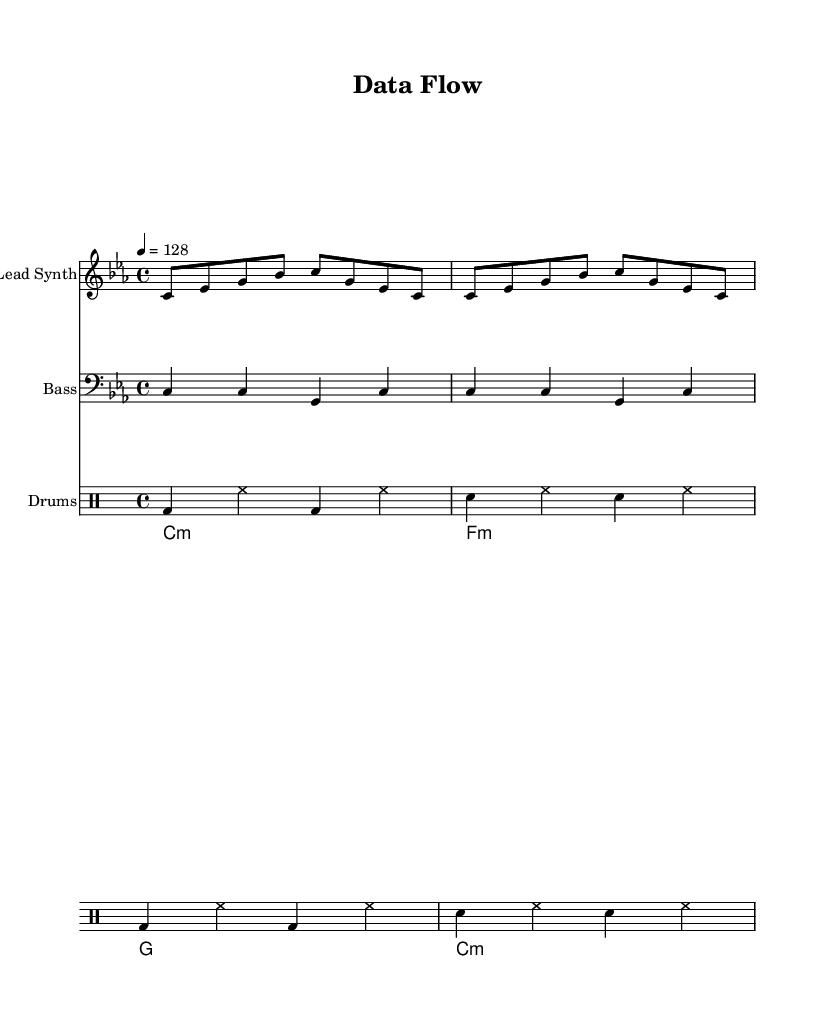What is the key signature of this music? The key signature is C minor, which consists of three flats (B♭, E♭, and A♭). This information can be found at the beginning of the staff.
Answer: C minor What is the time signature of this music? The time signature is located at the beginning of the sheet music and shows a 4 over 4, indicating that there are four beats per measure.
Answer: 4/4 What is the tempo marking of this music? The tempo marking indicates a speed of 128 beats per minute, which is specified in the tempo instruction at the beginning of the score.
Answer: 128 How many measures are in the lead synth part? The lead synth part has 4 measures, which is evident from counting the repeated sections that form the complete phrase.
Answer: 4 What type of chords are used in the pad chords section? The pad chords primarily use minor chords, as indicated by the ":m" notation next to the C, F, and G chords, showing they are minor.
Answer: Minor How many different instruments are used in this piece of music? There are three different instruments notated in the score: Lead Synth, Bass, and Drums, each presented on a separate staff.
Answer: 3 What rhythmic pattern is used in the percussion section? The percussion section displays a consistent pattern of bass drum and snare hits, alternating with hi-hat strokes, which can be observed across the repeated measures.
Answer: Alternating bass and snare with hi-hat 